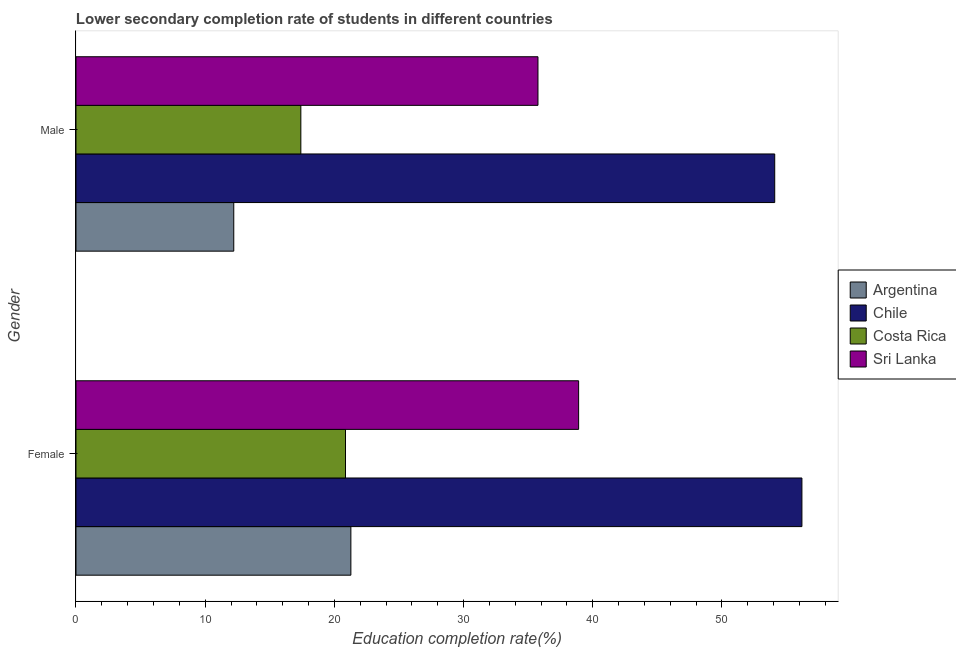How many different coloured bars are there?
Give a very brief answer. 4. Are the number of bars per tick equal to the number of legend labels?
Your answer should be very brief. Yes. How many bars are there on the 2nd tick from the bottom?
Your answer should be very brief. 4. What is the education completion rate of male students in Argentina?
Provide a short and direct response. 12.21. Across all countries, what is the maximum education completion rate of male students?
Keep it short and to the point. 54.09. Across all countries, what is the minimum education completion rate of male students?
Provide a succinct answer. 12.21. In which country was the education completion rate of female students minimum?
Ensure brevity in your answer.  Costa Rica. What is the total education completion rate of female students in the graph?
Ensure brevity in your answer.  137.24. What is the difference between the education completion rate of female students in Chile and that in Costa Rica?
Your answer should be very brief. 35.33. What is the difference between the education completion rate of female students in Costa Rica and the education completion rate of male students in Sri Lanka?
Give a very brief answer. -14.9. What is the average education completion rate of female students per country?
Your answer should be very brief. 34.31. What is the difference between the education completion rate of male students and education completion rate of female students in Costa Rica?
Give a very brief answer. -3.46. What is the ratio of the education completion rate of male students in Sri Lanka to that in Costa Rica?
Provide a succinct answer. 2.05. Is the education completion rate of female students in Sri Lanka less than that in Chile?
Your response must be concise. Yes. In how many countries, is the education completion rate of male students greater than the average education completion rate of male students taken over all countries?
Your response must be concise. 2. What does the 3rd bar from the top in Female represents?
Make the answer very short. Chile. What does the 2nd bar from the bottom in Male represents?
Offer a very short reply. Chile. Are all the bars in the graph horizontal?
Your response must be concise. Yes. What is the difference between two consecutive major ticks on the X-axis?
Provide a short and direct response. 10. Are the values on the major ticks of X-axis written in scientific E-notation?
Offer a very short reply. No. Does the graph contain any zero values?
Your answer should be compact. No. Where does the legend appear in the graph?
Provide a short and direct response. Center right. How are the legend labels stacked?
Offer a terse response. Vertical. What is the title of the graph?
Your response must be concise. Lower secondary completion rate of students in different countries. Does "Brunei Darussalam" appear as one of the legend labels in the graph?
Keep it short and to the point. No. What is the label or title of the X-axis?
Offer a very short reply. Education completion rate(%). What is the Education completion rate(%) of Argentina in Female?
Your answer should be very brief. 21.28. What is the Education completion rate(%) in Chile in Female?
Offer a terse response. 56.19. What is the Education completion rate(%) of Costa Rica in Female?
Give a very brief answer. 20.86. What is the Education completion rate(%) in Sri Lanka in Female?
Make the answer very short. 38.91. What is the Education completion rate(%) of Argentina in Male?
Your answer should be very brief. 12.21. What is the Education completion rate(%) of Chile in Male?
Give a very brief answer. 54.09. What is the Education completion rate(%) in Costa Rica in Male?
Offer a terse response. 17.41. What is the Education completion rate(%) of Sri Lanka in Male?
Provide a succinct answer. 35.76. Across all Gender, what is the maximum Education completion rate(%) in Argentina?
Offer a terse response. 21.28. Across all Gender, what is the maximum Education completion rate(%) in Chile?
Provide a short and direct response. 56.19. Across all Gender, what is the maximum Education completion rate(%) in Costa Rica?
Your answer should be very brief. 20.86. Across all Gender, what is the maximum Education completion rate(%) in Sri Lanka?
Your response must be concise. 38.91. Across all Gender, what is the minimum Education completion rate(%) of Argentina?
Provide a short and direct response. 12.21. Across all Gender, what is the minimum Education completion rate(%) in Chile?
Ensure brevity in your answer.  54.09. Across all Gender, what is the minimum Education completion rate(%) in Costa Rica?
Provide a short and direct response. 17.41. Across all Gender, what is the minimum Education completion rate(%) in Sri Lanka?
Your answer should be compact. 35.76. What is the total Education completion rate(%) in Argentina in the graph?
Offer a terse response. 33.49. What is the total Education completion rate(%) in Chile in the graph?
Your answer should be very brief. 110.28. What is the total Education completion rate(%) in Costa Rica in the graph?
Your answer should be very brief. 38.27. What is the total Education completion rate(%) of Sri Lanka in the graph?
Give a very brief answer. 74.67. What is the difference between the Education completion rate(%) of Argentina in Female and that in Male?
Give a very brief answer. 9.07. What is the difference between the Education completion rate(%) in Chile in Female and that in Male?
Provide a short and direct response. 2.1. What is the difference between the Education completion rate(%) in Costa Rica in Female and that in Male?
Make the answer very short. 3.46. What is the difference between the Education completion rate(%) in Sri Lanka in Female and that in Male?
Give a very brief answer. 3.15. What is the difference between the Education completion rate(%) in Argentina in Female and the Education completion rate(%) in Chile in Male?
Your answer should be compact. -32.81. What is the difference between the Education completion rate(%) in Argentina in Female and the Education completion rate(%) in Costa Rica in Male?
Offer a very short reply. 3.87. What is the difference between the Education completion rate(%) of Argentina in Female and the Education completion rate(%) of Sri Lanka in Male?
Your answer should be compact. -14.48. What is the difference between the Education completion rate(%) in Chile in Female and the Education completion rate(%) in Costa Rica in Male?
Offer a terse response. 38.79. What is the difference between the Education completion rate(%) in Chile in Female and the Education completion rate(%) in Sri Lanka in Male?
Provide a succinct answer. 20.43. What is the difference between the Education completion rate(%) of Costa Rica in Female and the Education completion rate(%) of Sri Lanka in Male?
Offer a very short reply. -14.9. What is the average Education completion rate(%) in Argentina per Gender?
Provide a short and direct response. 16.75. What is the average Education completion rate(%) in Chile per Gender?
Ensure brevity in your answer.  55.14. What is the average Education completion rate(%) in Costa Rica per Gender?
Your response must be concise. 19.13. What is the average Education completion rate(%) of Sri Lanka per Gender?
Make the answer very short. 37.33. What is the difference between the Education completion rate(%) in Argentina and Education completion rate(%) in Chile in Female?
Provide a short and direct response. -34.91. What is the difference between the Education completion rate(%) in Argentina and Education completion rate(%) in Costa Rica in Female?
Keep it short and to the point. 0.42. What is the difference between the Education completion rate(%) of Argentina and Education completion rate(%) of Sri Lanka in Female?
Make the answer very short. -17.63. What is the difference between the Education completion rate(%) of Chile and Education completion rate(%) of Costa Rica in Female?
Offer a terse response. 35.33. What is the difference between the Education completion rate(%) of Chile and Education completion rate(%) of Sri Lanka in Female?
Make the answer very short. 17.28. What is the difference between the Education completion rate(%) in Costa Rica and Education completion rate(%) in Sri Lanka in Female?
Ensure brevity in your answer.  -18.05. What is the difference between the Education completion rate(%) of Argentina and Education completion rate(%) of Chile in Male?
Provide a succinct answer. -41.87. What is the difference between the Education completion rate(%) in Argentina and Education completion rate(%) in Costa Rica in Male?
Provide a succinct answer. -5.19. What is the difference between the Education completion rate(%) in Argentina and Education completion rate(%) in Sri Lanka in Male?
Your answer should be very brief. -23.55. What is the difference between the Education completion rate(%) of Chile and Education completion rate(%) of Costa Rica in Male?
Offer a terse response. 36.68. What is the difference between the Education completion rate(%) of Chile and Education completion rate(%) of Sri Lanka in Male?
Make the answer very short. 18.33. What is the difference between the Education completion rate(%) in Costa Rica and Education completion rate(%) in Sri Lanka in Male?
Offer a very short reply. -18.35. What is the ratio of the Education completion rate(%) in Argentina in Female to that in Male?
Provide a short and direct response. 1.74. What is the ratio of the Education completion rate(%) in Chile in Female to that in Male?
Your answer should be compact. 1.04. What is the ratio of the Education completion rate(%) of Costa Rica in Female to that in Male?
Provide a succinct answer. 1.2. What is the ratio of the Education completion rate(%) in Sri Lanka in Female to that in Male?
Your response must be concise. 1.09. What is the difference between the highest and the second highest Education completion rate(%) of Argentina?
Give a very brief answer. 9.07. What is the difference between the highest and the second highest Education completion rate(%) in Chile?
Offer a very short reply. 2.1. What is the difference between the highest and the second highest Education completion rate(%) in Costa Rica?
Give a very brief answer. 3.46. What is the difference between the highest and the second highest Education completion rate(%) in Sri Lanka?
Give a very brief answer. 3.15. What is the difference between the highest and the lowest Education completion rate(%) in Argentina?
Your response must be concise. 9.07. What is the difference between the highest and the lowest Education completion rate(%) of Chile?
Your response must be concise. 2.1. What is the difference between the highest and the lowest Education completion rate(%) of Costa Rica?
Give a very brief answer. 3.46. What is the difference between the highest and the lowest Education completion rate(%) in Sri Lanka?
Ensure brevity in your answer.  3.15. 